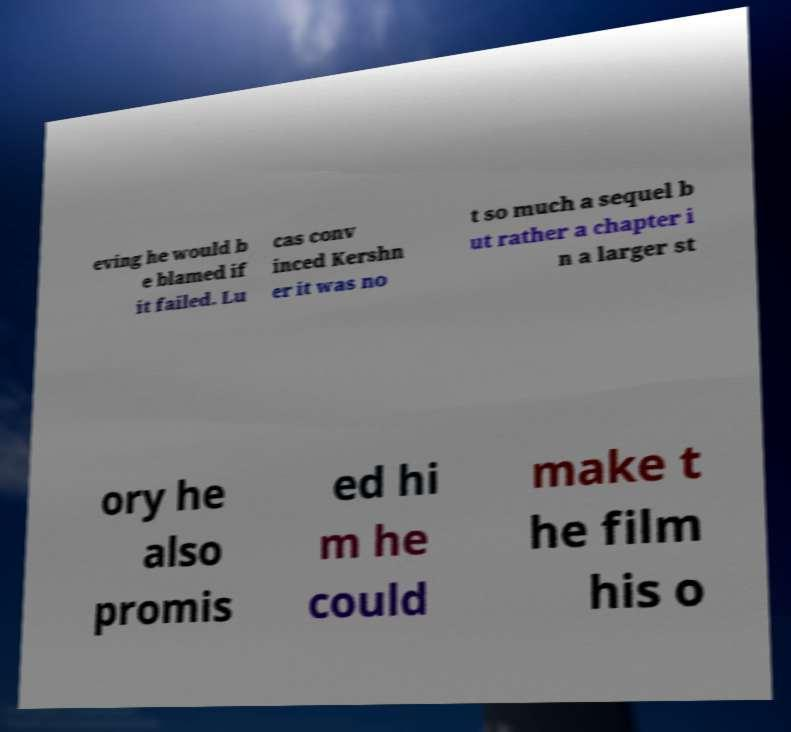Please read and relay the text visible in this image. What does it say? eving he would b e blamed if it failed. Lu cas conv inced Kershn er it was no t so much a sequel b ut rather a chapter i n a larger st ory he also promis ed hi m he could make t he film his o 